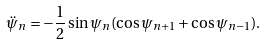Convert formula to latex. <formula><loc_0><loc_0><loc_500><loc_500>\ddot { \psi } _ { n } = - \frac { 1 } { 2 } \sin \psi _ { n } ( \cos \psi _ { n + 1 } + \cos \psi _ { n - 1 } ) .</formula> 